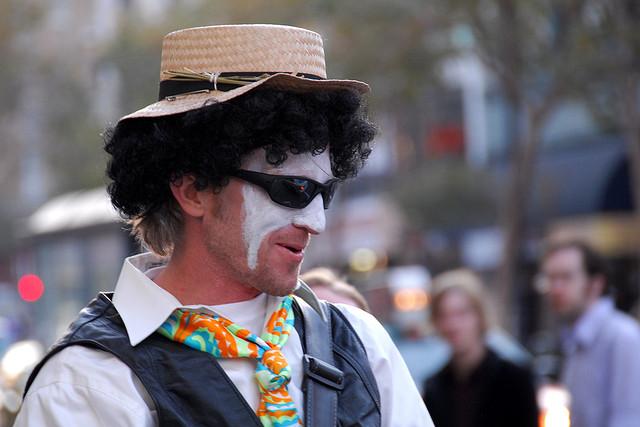Is the man wearing a wig?
Concise answer only. Yes. What type of hat is he wearing?
Short answer required. Straw. Is the man wearing a tie?
Short answer required. Yes. Is he wearing a knitted hat?
Concise answer only. No. How many people are in the background?
Answer briefly. 3. 